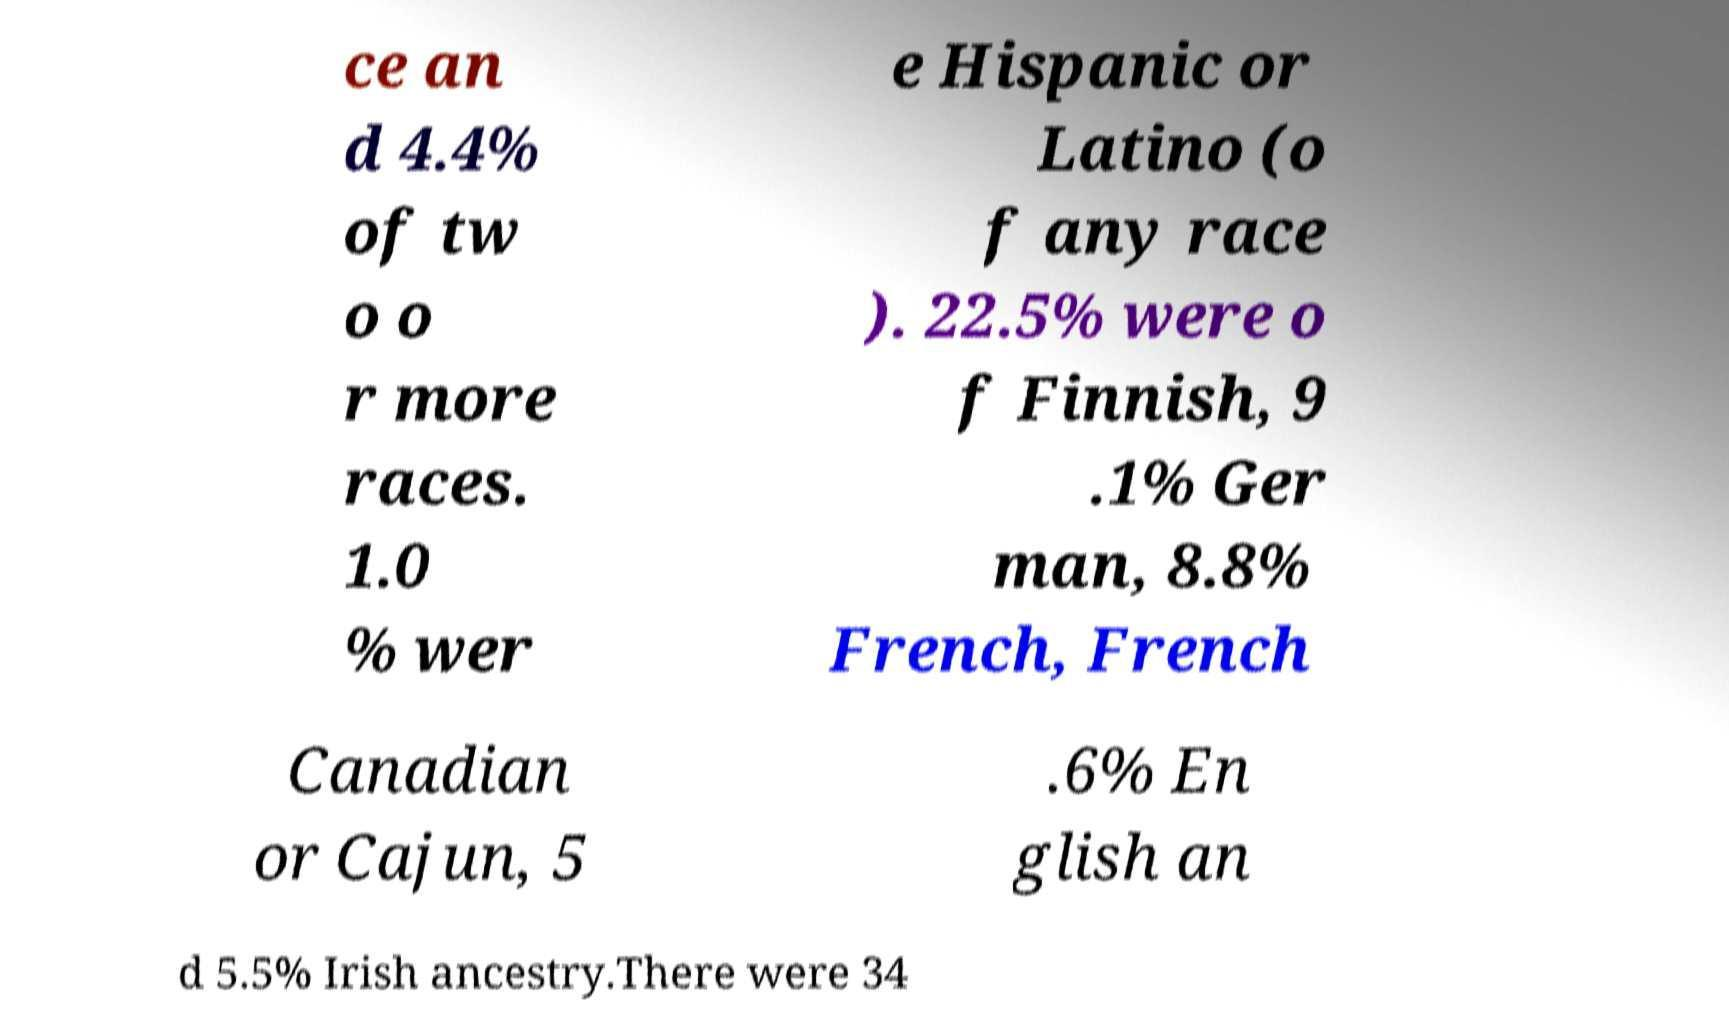Please identify and transcribe the text found in this image. ce an d 4.4% of tw o o r more races. 1.0 % wer e Hispanic or Latino (o f any race ). 22.5% were o f Finnish, 9 .1% Ger man, 8.8% French, French Canadian or Cajun, 5 .6% En glish an d 5.5% Irish ancestry.There were 34 